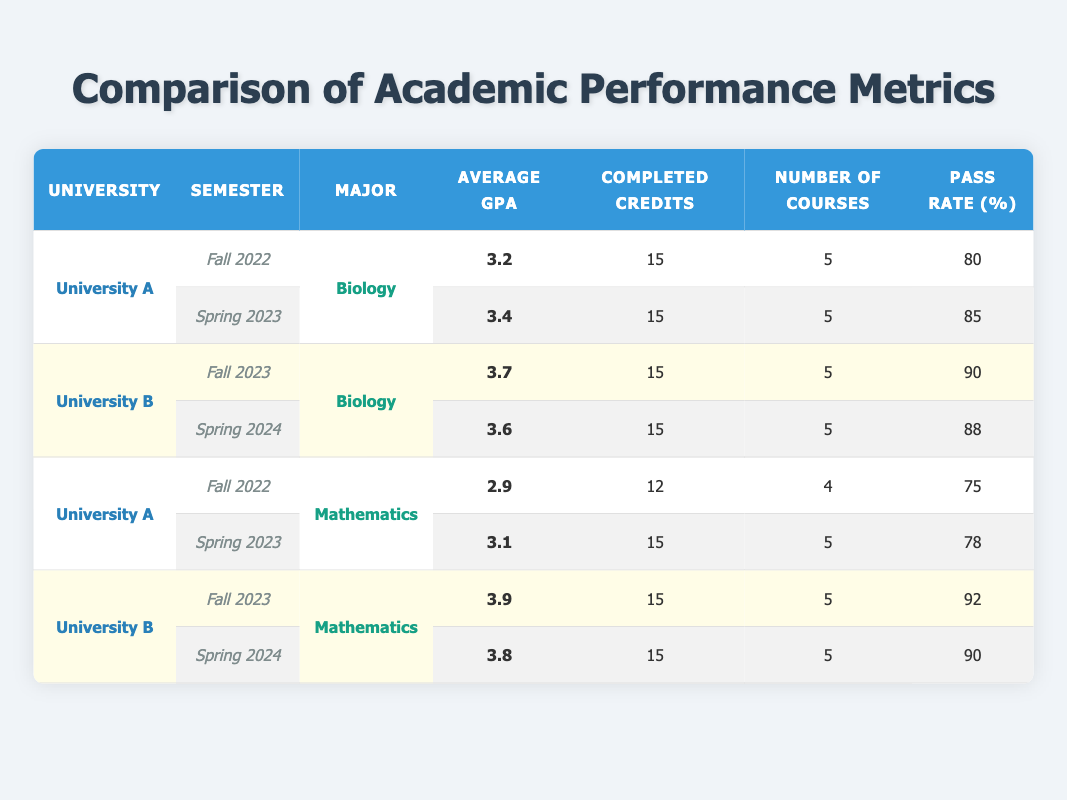What is the average GPA for Biology majors at University B in Spring 2024? The table indicates that the average GPA for Biology majors at University B in Spring 2024 is 3.6. This is directly retrieved from the corresponding row.
Answer: 3.6 How many courses did students complete in Fall 2022 at University A for both majors? The table shows that for Biology, 5 courses were completed in Fall 2022. For Mathematics, 4 courses were completed. Adding these together (5 + 4), students completed a total of 9 courses in Fall 2022 at University A.
Answer: 9 What was the pass rate percentage for Mathematics majors at University A in Spring 2023? The table indicates that the pass rate percentage for Mathematics majors at University A in Spring 2023 is 78%. This information can be directly found in the relevant row of the table.
Answer: 78 Did the average GPA for Biology majors increase or decrease from Fall 2022 to Spring 2023 at University A? The average GPA for Biology in Fall 2022 is 3.2, and it increased to 3.4 in Spring 2023. Since 3.4 is greater than 3.2, the average GPA for Biology majors increased.
Answer: Increased What is the difference in average GPA between Mathematics majors at University B and University A in Fall 2023? For Mathematics, the average GPA at University B in Fall 2023 is 3.9, while at University A, the average GPA is 3.1 in Spring 2023. To find the difference: 3.9 - 3.1 = 0.8. Thus, the difference is 0.8.
Answer: 0.8 What was the completed credits count for both semesters in University B for Mathematics majors? In Fall 2023 at University B, the completed credits for Mathematics majors is 15, and it remains the same in Spring 2024 at 15 credits. Therefore, for both semesters, the completed credits are consistently 15.
Answer: 15 Is the pass rate for Mathematics majors at University B higher than that at University A in Spring 2023? The pass rate for Mathematics at University B in Spring 2024 is 90%. In contrast, the pass rate at University A in Spring 2023 is 78%. Since 90% is greater than 78%, the pass rate for Mathematics majors at University B is indeed higher.
Answer: Yes What is the sum of completed credits by Biology majors at University B across both semesters? The completed credits for Biology majors in Fall 2023 and Spring 2024 at University B are both 15. Summing these gives: 15 + 15 = 30. Thus, the total completed credits for Biology majors at University B is 30.
Answer: 30 Was the average GPA for students in Mathematics higher at University B than in University A in Spring 2024? The average GPA for Mathematics majors at University B in Spring 2024 is 3.8, whereas at University A in Spring 2023 it is 3.1. Since 3.8 is greater than 3.1, the average GPA for Mathematics at University B is higher.
Answer: Yes 